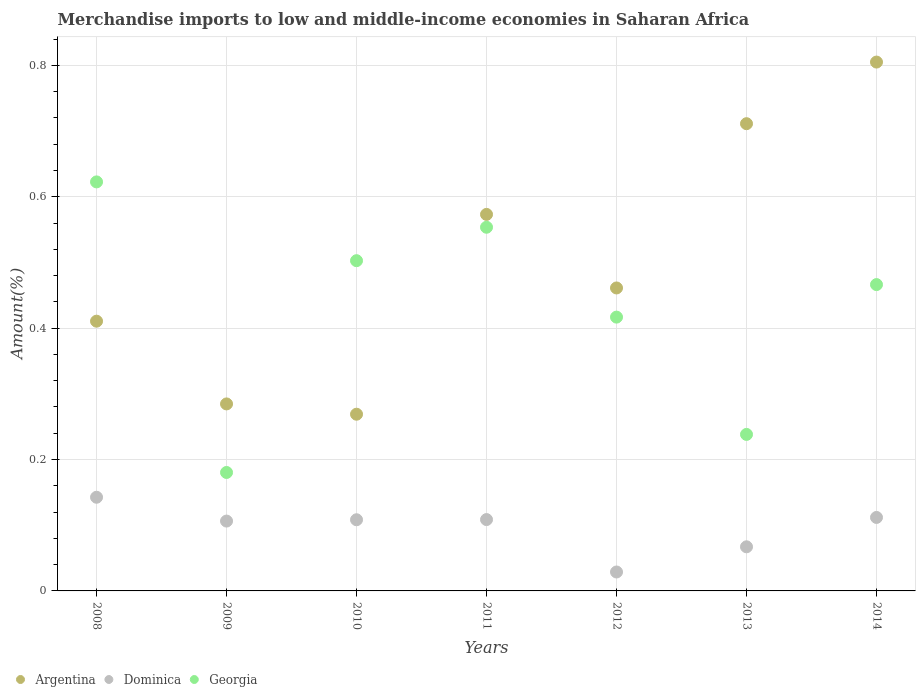Is the number of dotlines equal to the number of legend labels?
Provide a short and direct response. Yes. What is the percentage of amount earned from merchandise imports in Georgia in 2014?
Make the answer very short. 0.47. Across all years, what is the maximum percentage of amount earned from merchandise imports in Georgia?
Offer a terse response. 0.62. Across all years, what is the minimum percentage of amount earned from merchandise imports in Argentina?
Provide a succinct answer. 0.27. In which year was the percentage of amount earned from merchandise imports in Georgia maximum?
Offer a very short reply. 2008. What is the total percentage of amount earned from merchandise imports in Georgia in the graph?
Make the answer very short. 2.98. What is the difference between the percentage of amount earned from merchandise imports in Georgia in 2010 and that in 2014?
Keep it short and to the point. 0.04. What is the difference between the percentage of amount earned from merchandise imports in Georgia in 2014 and the percentage of amount earned from merchandise imports in Dominica in 2009?
Keep it short and to the point. 0.36. What is the average percentage of amount earned from merchandise imports in Dominica per year?
Provide a succinct answer. 0.1. In the year 2013, what is the difference between the percentage of amount earned from merchandise imports in Argentina and percentage of amount earned from merchandise imports in Georgia?
Make the answer very short. 0.47. What is the ratio of the percentage of amount earned from merchandise imports in Dominica in 2012 to that in 2013?
Give a very brief answer. 0.43. Is the percentage of amount earned from merchandise imports in Georgia in 2012 less than that in 2013?
Offer a terse response. No. What is the difference between the highest and the second highest percentage of amount earned from merchandise imports in Argentina?
Provide a short and direct response. 0.09. What is the difference between the highest and the lowest percentage of amount earned from merchandise imports in Dominica?
Keep it short and to the point. 0.11. Is it the case that in every year, the sum of the percentage of amount earned from merchandise imports in Argentina and percentage of amount earned from merchandise imports in Georgia  is greater than the percentage of amount earned from merchandise imports in Dominica?
Offer a terse response. Yes. Is the percentage of amount earned from merchandise imports in Georgia strictly less than the percentage of amount earned from merchandise imports in Dominica over the years?
Your answer should be very brief. No. Are the values on the major ticks of Y-axis written in scientific E-notation?
Offer a terse response. No. Does the graph contain grids?
Your answer should be compact. Yes. How many legend labels are there?
Give a very brief answer. 3. How are the legend labels stacked?
Keep it short and to the point. Horizontal. What is the title of the graph?
Offer a terse response. Merchandise imports to low and middle-income economies in Saharan Africa. What is the label or title of the X-axis?
Your answer should be compact. Years. What is the label or title of the Y-axis?
Your answer should be very brief. Amount(%). What is the Amount(%) in Argentina in 2008?
Provide a short and direct response. 0.41. What is the Amount(%) in Dominica in 2008?
Provide a short and direct response. 0.14. What is the Amount(%) of Georgia in 2008?
Make the answer very short. 0.62. What is the Amount(%) in Argentina in 2009?
Your answer should be compact. 0.28. What is the Amount(%) in Dominica in 2009?
Offer a very short reply. 0.11. What is the Amount(%) in Georgia in 2009?
Make the answer very short. 0.18. What is the Amount(%) of Argentina in 2010?
Offer a terse response. 0.27. What is the Amount(%) of Dominica in 2010?
Your answer should be very brief. 0.11. What is the Amount(%) of Georgia in 2010?
Your response must be concise. 0.5. What is the Amount(%) of Argentina in 2011?
Your answer should be very brief. 0.57. What is the Amount(%) of Dominica in 2011?
Your response must be concise. 0.11. What is the Amount(%) of Georgia in 2011?
Your answer should be compact. 0.55. What is the Amount(%) in Argentina in 2012?
Your answer should be very brief. 0.46. What is the Amount(%) of Dominica in 2012?
Give a very brief answer. 0.03. What is the Amount(%) of Georgia in 2012?
Your answer should be compact. 0.42. What is the Amount(%) in Argentina in 2013?
Offer a very short reply. 0.71. What is the Amount(%) of Dominica in 2013?
Your answer should be very brief. 0.07. What is the Amount(%) of Georgia in 2013?
Offer a terse response. 0.24. What is the Amount(%) of Argentina in 2014?
Ensure brevity in your answer.  0.81. What is the Amount(%) of Dominica in 2014?
Your answer should be very brief. 0.11. What is the Amount(%) of Georgia in 2014?
Offer a very short reply. 0.47. Across all years, what is the maximum Amount(%) in Argentina?
Offer a very short reply. 0.81. Across all years, what is the maximum Amount(%) of Dominica?
Keep it short and to the point. 0.14. Across all years, what is the maximum Amount(%) in Georgia?
Make the answer very short. 0.62. Across all years, what is the minimum Amount(%) of Argentina?
Your response must be concise. 0.27. Across all years, what is the minimum Amount(%) of Dominica?
Make the answer very short. 0.03. Across all years, what is the minimum Amount(%) of Georgia?
Offer a very short reply. 0.18. What is the total Amount(%) in Argentina in the graph?
Your answer should be compact. 3.52. What is the total Amount(%) in Dominica in the graph?
Make the answer very short. 0.67. What is the total Amount(%) of Georgia in the graph?
Your response must be concise. 2.98. What is the difference between the Amount(%) of Argentina in 2008 and that in 2009?
Keep it short and to the point. 0.13. What is the difference between the Amount(%) in Dominica in 2008 and that in 2009?
Offer a very short reply. 0.04. What is the difference between the Amount(%) of Georgia in 2008 and that in 2009?
Provide a short and direct response. 0.44. What is the difference between the Amount(%) in Argentina in 2008 and that in 2010?
Make the answer very short. 0.14. What is the difference between the Amount(%) in Dominica in 2008 and that in 2010?
Give a very brief answer. 0.03. What is the difference between the Amount(%) in Georgia in 2008 and that in 2010?
Make the answer very short. 0.12. What is the difference between the Amount(%) in Argentina in 2008 and that in 2011?
Offer a terse response. -0.16. What is the difference between the Amount(%) of Dominica in 2008 and that in 2011?
Give a very brief answer. 0.03. What is the difference between the Amount(%) of Georgia in 2008 and that in 2011?
Keep it short and to the point. 0.07. What is the difference between the Amount(%) in Argentina in 2008 and that in 2012?
Ensure brevity in your answer.  -0.05. What is the difference between the Amount(%) of Dominica in 2008 and that in 2012?
Give a very brief answer. 0.11. What is the difference between the Amount(%) in Georgia in 2008 and that in 2012?
Give a very brief answer. 0.21. What is the difference between the Amount(%) in Argentina in 2008 and that in 2013?
Your answer should be compact. -0.3. What is the difference between the Amount(%) of Dominica in 2008 and that in 2013?
Offer a very short reply. 0.08. What is the difference between the Amount(%) in Georgia in 2008 and that in 2013?
Offer a terse response. 0.38. What is the difference between the Amount(%) of Argentina in 2008 and that in 2014?
Offer a very short reply. -0.39. What is the difference between the Amount(%) of Dominica in 2008 and that in 2014?
Offer a very short reply. 0.03. What is the difference between the Amount(%) of Georgia in 2008 and that in 2014?
Offer a very short reply. 0.16. What is the difference between the Amount(%) of Argentina in 2009 and that in 2010?
Ensure brevity in your answer.  0.02. What is the difference between the Amount(%) of Dominica in 2009 and that in 2010?
Keep it short and to the point. -0. What is the difference between the Amount(%) in Georgia in 2009 and that in 2010?
Offer a very short reply. -0.32. What is the difference between the Amount(%) in Argentina in 2009 and that in 2011?
Your response must be concise. -0.29. What is the difference between the Amount(%) in Dominica in 2009 and that in 2011?
Provide a succinct answer. -0. What is the difference between the Amount(%) of Georgia in 2009 and that in 2011?
Make the answer very short. -0.37. What is the difference between the Amount(%) of Argentina in 2009 and that in 2012?
Your response must be concise. -0.18. What is the difference between the Amount(%) in Dominica in 2009 and that in 2012?
Provide a short and direct response. 0.08. What is the difference between the Amount(%) of Georgia in 2009 and that in 2012?
Your answer should be very brief. -0.24. What is the difference between the Amount(%) of Argentina in 2009 and that in 2013?
Your answer should be compact. -0.43. What is the difference between the Amount(%) in Dominica in 2009 and that in 2013?
Provide a succinct answer. 0.04. What is the difference between the Amount(%) of Georgia in 2009 and that in 2013?
Give a very brief answer. -0.06. What is the difference between the Amount(%) of Argentina in 2009 and that in 2014?
Your answer should be compact. -0.52. What is the difference between the Amount(%) in Dominica in 2009 and that in 2014?
Give a very brief answer. -0.01. What is the difference between the Amount(%) in Georgia in 2009 and that in 2014?
Ensure brevity in your answer.  -0.29. What is the difference between the Amount(%) of Argentina in 2010 and that in 2011?
Provide a succinct answer. -0.3. What is the difference between the Amount(%) of Dominica in 2010 and that in 2011?
Provide a succinct answer. -0. What is the difference between the Amount(%) of Georgia in 2010 and that in 2011?
Give a very brief answer. -0.05. What is the difference between the Amount(%) in Argentina in 2010 and that in 2012?
Make the answer very short. -0.19. What is the difference between the Amount(%) of Dominica in 2010 and that in 2012?
Offer a very short reply. 0.08. What is the difference between the Amount(%) in Georgia in 2010 and that in 2012?
Provide a short and direct response. 0.09. What is the difference between the Amount(%) in Argentina in 2010 and that in 2013?
Your response must be concise. -0.44. What is the difference between the Amount(%) in Dominica in 2010 and that in 2013?
Ensure brevity in your answer.  0.04. What is the difference between the Amount(%) in Georgia in 2010 and that in 2013?
Make the answer very short. 0.26. What is the difference between the Amount(%) of Argentina in 2010 and that in 2014?
Provide a short and direct response. -0.54. What is the difference between the Amount(%) of Dominica in 2010 and that in 2014?
Your answer should be very brief. -0. What is the difference between the Amount(%) of Georgia in 2010 and that in 2014?
Your answer should be very brief. 0.04. What is the difference between the Amount(%) of Argentina in 2011 and that in 2012?
Give a very brief answer. 0.11. What is the difference between the Amount(%) of Dominica in 2011 and that in 2012?
Your answer should be very brief. 0.08. What is the difference between the Amount(%) of Georgia in 2011 and that in 2012?
Make the answer very short. 0.14. What is the difference between the Amount(%) of Argentina in 2011 and that in 2013?
Ensure brevity in your answer.  -0.14. What is the difference between the Amount(%) of Dominica in 2011 and that in 2013?
Ensure brevity in your answer.  0.04. What is the difference between the Amount(%) in Georgia in 2011 and that in 2013?
Ensure brevity in your answer.  0.32. What is the difference between the Amount(%) in Argentina in 2011 and that in 2014?
Offer a terse response. -0.23. What is the difference between the Amount(%) of Dominica in 2011 and that in 2014?
Ensure brevity in your answer.  -0. What is the difference between the Amount(%) in Georgia in 2011 and that in 2014?
Make the answer very short. 0.09. What is the difference between the Amount(%) in Argentina in 2012 and that in 2013?
Your answer should be very brief. -0.25. What is the difference between the Amount(%) in Dominica in 2012 and that in 2013?
Give a very brief answer. -0.04. What is the difference between the Amount(%) in Georgia in 2012 and that in 2013?
Ensure brevity in your answer.  0.18. What is the difference between the Amount(%) of Argentina in 2012 and that in 2014?
Your response must be concise. -0.34. What is the difference between the Amount(%) of Dominica in 2012 and that in 2014?
Give a very brief answer. -0.08. What is the difference between the Amount(%) in Georgia in 2012 and that in 2014?
Provide a succinct answer. -0.05. What is the difference between the Amount(%) of Argentina in 2013 and that in 2014?
Give a very brief answer. -0.09. What is the difference between the Amount(%) of Dominica in 2013 and that in 2014?
Provide a short and direct response. -0.04. What is the difference between the Amount(%) in Georgia in 2013 and that in 2014?
Provide a short and direct response. -0.23. What is the difference between the Amount(%) in Argentina in 2008 and the Amount(%) in Dominica in 2009?
Your answer should be very brief. 0.3. What is the difference between the Amount(%) of Argentina in 2008 and the Amount(%) of Georgia in 2009?
Keep it short and to the point. 0.23. What is the difference between the Amount(%) of Dominica in 2008 and the Amount(%) of Georgia in 2009?
Offer a very short reply. -0.04. What is the difference between the Amount(%) in Argentina in 2008 and the Amount(%) in Dominica in 2010?
Give a very brief answer. 0.3. What is the difference between the Amount(%) of Argentina in 2008 and the Amount(%) of Georgia in 2010?
Offer a terse response. -0.09. What is the difference between the Amount(%) of Dominica in 2008 and the Amount(%) of Georgia in 2010?
Your answer should be very brief. -0.36. What is the difference between the Amount(%) of Argentina in 2008 and the Amount(%) of Dominica in 2011?
Your answer should be very brief. 0.3. What is the difference between the Amount(%) in Argentina in 2008 and the Amount(%) in Georgia in 2011?
Your answer should be compact. -0.14. What is the difference between the Amount(%) of Dominica in 2008 and the Amount(%) of Georgia in 2011?
Your answer should be very brief. -0.41. What is the difference between the Amount(%) of Argentina in 2008 and the Amount(%) of Dominica in 2012?
Give a very brief answer. 0.38. What is the difference between the Amount(%) of Argentina in 2008 and the Amount(%) of Georgia in 2012?
Your answer should be very brief. -0.01. What is the difference between the Amount(%) in Dominica in 2008 and the Amount(%) in Georgia in 2012?
Give a very brief answer. -0.27. What is the difference between the Amount(%) in Argentina in 2008 and the Amount(%) in Dominica in 2013?
Your answer should be very brief. 0.34. What is the difference between the Amount(%) in Argentina in 2008 and the Amount(%) in Georgia in 2013?
Provide a short and direct response. 0.17. What is the difference between the Amount(%) of Dominica in 2008 and the Amount(%) of Georgia in 2013?
Offer a very short reply. -0.1. What is the difference between the Amount(%) of Argentina in 2008 and the Amount(%) of Dominica in 2014?
Your answer should be very brief. 0.3. What is the difference between the Amount(%) of Argentina in 2008 and the Amount(%) of Georgia in 2014?
Ensure brevity in your answer.  -0.06. What is the difference between the Amount(%) of Dominica in 2008 and the Amount(%) of Georgia in 2014?
Ensure brevity in your answer.  -0.32. What is the difference between the Amount(%) in Argentina in 2009 and the Amount(%) in Dominica in 2010?
Your response must be concise. 0.18. What is the difference between the Amount(%) in Argentina in 2009 and the Amount(%) in Georgia in 2010?
Make the answer very short. -0.22. What is the difference between the Amount(%) of Dominica in 2009 and the Amount(%) of Georgia in 2010?
Give a very brief answer. -0.4. What is the difference between the Amount(%) in Argentina in 2009 and the Amount(%) in Dominica in 2011?
Provide a short and direct response. 0.18. What is the difference between the Amount(%) of Argentina in 2009 and the Amount(%) of Georgia in 2011?
Your response must be concise. -0.27. What is the difference between the Amount(%) in Dominica in 2009 and the Amount(%) in Georgia in 2011?
Your answer should be very brief. -0.45. What is the difference between the Amount(%) in Argentina in 2009 and the Amount(%) in Dominica in 2012?
Your answer should be compact. 0.26. What is the difference between the Amount(%) in Argentina in 2009 and the Amount(%) in Georgia in 2012?
Your answer should be very brief. -0.13. What is the difference between the Amount(%) in Dominica in 2009 and the Amount(%) in Georgia in 2012?
Provide a succinct answer. -0.31. What is the difference between the Amount(%) of Argentina in 2009 and the Amount(%) of Dominica in 2013?
Give a very brief answer. 0.22. What is the difference between the Amount(%) of Argentina in 2009 and the Amount(%) of Georgia in 2013?
Offer a very short reply. 0.05. What is the difference between the Amount(%) in Dominica in 2009 and the Amount(%) in Georgia in 2013?
Make the answer very short. -0.13. What is the difference between the Amount(%) in Argentina in 2009 and the Amount(%) in Dominica in 2014?
Offer a very short reply. 0.17. What is the difference between the Amount(%) of Argentina in 2009 and the Amount(%) of Georgia in 2014?
Offer a very short reply. -0.18. What is the difference between the Amount(%) of Dominica in 2009 and the Amount(%) of Georgia in 2014?
Offer a terse response. -0.36. What is the difference between the Amount(%) of Argentina in 2010 and the Amount(%) of Dominica in 2011?
Offer a terse response. 0.16. What is the difference between the Amount(%) in Argentina in 2010 and the Amount(%) in Georgia in 2011?
Your answer should be compact. -0.28. What is the difference between the Amount(%) of Dominica in 2010 and the Amount(%) of Georgia in 2011?
Provide a succinct answer. -0.45. What is the difference between the Amount(%) in Argentina in 2010 and the Amount(%) in Dominica in 2012?
Your answer should be very brief. 0.24. What is the difference between the Amount(%) in Argentina in 2010 and the Amount(%) in Georgia in 2012?
Provide a succinct answer. -0.15. What is the difference between the Amount(%) in Dominica in 2010 and the Amount(%) in Georgia in 2012?
Your answer should be very brief. -0.31. What is the difference between the Amount(%) of Argentina in 2010 and the Amount(%) of Dominica in 2013?
Ensure brevity in your answer.  0.2. What is the difference between the Amount(%) of Argentina in 2010 and the Amount(%) of Georgia in 2013?
Make the answer very short. 0.03. What is the difference between the Amount(%) of Dominica in 2010 and the Amount(%) of Georgia in 2013?
Give a very brief answer. -0.13. What is the difference between the Amount(%) of Argentina in 2010 and the Amount(%) of Dominica in 2014?
Your answer should be very brief. 0.16. What is the difference between the Amount(%) in Argentina in 2010 and the Amount(%) in Georgia in 2014?
Provide a succinct answer. -0.2. What is the difference between the Amount(%) of Dominica in 2010 and the Amount(%) of Georgia in 2014?
Your answer should be compact. -0.36. What is the difference between the Amount(%) in Argentina in 2011 and the Amount(%) in Dominica in 2012?
Provide a short and direct response. 0.54. What is the difference between the Amount(%) of Argentina in 2011 and the Amount(%) of Georgia in 2012?
Provide a short and direct response. 0.16. What is the difference between the Amount(%) of Dominica in 2011 and the Amount(%) of Georgia in 2012?
Provide a short and direct response. -0.31. What is the difference between the Amount(%) in Argentina in 2011 and the Amount(%) in Dominica in 2013?
Offer a terse response. 0.51. What is the difference between the Amount(%) in Argentina in 2011 and the Amount(%) in Georgia in 2013?
Offer a very short reply. 0.33. What is the difference between the Amount(%) in Dominica in 2011 and the Amount(%) in Georgia in 2013?
Your response must be concise. -0.13. What is the difference between the Amount(%) in Argentina in 2011 and the Amount(%) in Dominica in 2014?
Ensure brevity in your answer.  0.46. What is the difference between the Amount(%) in Argentina in 2011 and the Amount(%) in Georgia in 2014?
Make the answer very short. 0.11. What is the difference between the Amount(%) of Dominica in 2011 and the Amount(%) of Georgia in 2014?
Ensure brevity in your answer.  -0.36. What is the difference between the Amount(%) in Argentina in 2012 and the Amount(%) in Dominica in 2013?
Provide a succinct answer. 0.39. What is the difference between the Amount(%) of Argentina in 2012 and the Amount(%) of Georgia in 2013?
Offer a very short reply. 0.22. What is the difference between the Amount(%) of Dominica in 2012 and the Amount(%) of Georgia in 2013?
Offer a very short reply. -0.21. What is the difference between the Amount(%) of Argentina in 2012 and the Amount(%) of Dominica in 2014?
Provide a short and direct response. 0.35. What is the difference between the Amount(%) in Argentina in 2012 and the Amount(%) in Georgia in 2014?
Provide a succinct answer. -0.01. What is the difference between the Amount(%) of Dominica in 2012 and the Amount(%) of Georgia in 2014?
Provide a succinct answer. -0.44. What is the difference between the Amount(%) in Argentina in 2013 and the Amount(%) in Dominica in 2014?
Provide a short and direct response. 0.6. What is the difference between the Amount(%) in Argentina in 2013 and the Amount(%) in Georgia in 2014?
Your response must be concise. 0.24. What is the difference between the Amount(%) of Dominica in 2013 and the Amount(%) of Georgia in 2014?
Your response must be concise. -0.4. What is the average Amount(%) of Argentina per year?
Offer a terse response. 0.5. What is the average Amount(%) of Dominica per year?
Offer a terse response. 0.1. What is the average Amount(%) in Georgia per year?
Keep it short and to the point. 0.43. In the year 2008, what is the difference between the Amount(%) of Argentina and Amount(%) of Dominica?
Keep it short and to the point. 0.27. In the year 2008, what is the difference between the Amount(%) of Argentina and Amount(%) of Georgia?
Offer a terse response. -0.21. In the year 2008, what is the difference between the Amount(%) in Dominica and Amount(%) in Georgia?
Offer a very short reply. -0.48. In the year 2009, what is the difference between the Amount(%) in Argentina and Amount(%) in Dominica?
Offer a very short reply. 0.18. In the year 2009, what is the difference between the Amount(%) of Argentina and Amount(%) of Georgia?
Your answer should be very brief. 0.1. In the year 2009, what is the difference between the Amount(%) of Dominica and Amount(%) of Georgia?
Ensure brevity in your answer.  -0.07. In the year 2010, what is the difference between the Amount(%) in Argentina and Amount(%) in Dominica?
Offer a terse response. 0.16. In the year 2010, what is the difference between the Amount(%) of Argentina and Amount(%) of Georgia?
Offer a very short reply. -0.23. In the year 2010, what is the difference between the Amount(%) in Dominica and Amount(%) in Georgia?
Your answer should be very brief. -0.39. In the year 2011, what is the difference between the Amount(%) of Argentina and Amount(%) of Dominica?
Provide a short and direct response. 0.46. In the year 2011, what is the difference between the Amount(%) in Argentina and Amount(%) in Georgia?
Your answer should be very brief. 0.02. In the year 2011, what is the difference between the Amount(%) in Dominica and Amount(%) in Georgia?
Provide a short and direct response. -0.45. In the year 2012, what is the difference between the Amount(%) in Argentina and Amount(%) in Dominica?
Your answer should be very brief. 0.43. In the year 2012, what is the difference between the Amount(%) in Argentina and Amount(%) in Georgia?
Give a very brief answer. 0.04. In the year 2012, what is the difference between the Amount(%) in Dominica and Amount(%) in Georgia?
Keep it short and to the point. -0.39. In the year 2013, what is the difference between the Amount(%) of Argentina and Amount(%) of Dominica?
Make the answer very short. 0.64. In the year 2013, what is the difference between the Amount(%) in Argentina and Amount(%) in Georgia?
Make the answer very short. 0.47. In the year 2013, what is the difference between the Amount(%) in Dominica and Amount(%) in Georgia?
Offer a very short reply. -0.17. In the year 2014, what is the difference between the Amount(%) in Argentina and Amount(%) in Dominica?
Give a very brief answer. 0.69. In the year 2014, what is the difference between the Amount(%) in Argentina and Amount(%) in Georgia?
Your response must be concise. 0.34. In the year 2014, what is the difference between the Amount(%) in Dominica and Amount(%) in Georgia?
Provide a short and direct response. -0.35. What is the ratio of the Amount(%) of Argentina in 2008 to that in 2009?
Your response must be concise. 1.44. What is the ratio of the Amount(%) in Dominica in 2008 to that in 2009?
Offer a very short reply. 1.34. What is the ratio of the Amount(%) in Georgia in 2008 to that in 2009?
Provide a succinct answer. 3.45. What is the ratio of the Amount(%) of Argentina in 2008 to that in 2010?
Offer a terse response. 1.53. What is the ratio of the Amount(%) of Dominica in 2008 to that in 2010?
Provide a succinct answer. 1.32. What is the ratio of the Amount(%) of Georgia in 2008 to that in 2010?
Make the answer very short. 1.24. What is the ratio of the Amount(%) in Argentina in 2008 to that in 2011?
Your answer should be compact. 0.72. What is the ratio of the Amount(%) of Dominica in 2008 to that in 2011?
Your answer should be very brief. 1.31. What is the ratio of the Amount(%) of Georgia in 2008 to that in 2011?
Make the answer very short. 1.12. What is the ratio of the Amount(%) of Argentina in 2008 to that in 2012?
Your answer should be compact. 0.89. What is the ratio of the Amount(%) of Dominica in 2008 to that in 2012?
Make the answer very short. 4.95. What is the ratio of the Amount(%) of Georgia in 2008 to that in 2012?
Keep it short and to the point. 1.49. What is the ratio of the Amount(%) in Argentina in 2008 to that in 2013?
Your answer should be very brief. 0.58. What is the ratio of the Amount(%) in Dominica in 2008 to that in 2013?
Make the answer very short. 2.12. What is the ratio of the Amount(%) in Georgia in 2008 to that in 2013?
Offer a terse response. 2.61. What is the ratio of the Amount(%) in Argentina in 2008 to that in 2014?
Offer a terse response. 0.51. What is the ratio of the Amount(%) in Dominica in 2008 to that in 2014?
Offer a terse response. 1.27. What is the ratio of the Amount(%) in Georgia in 2008 to that in 2014?
Your response must be concise. 1.34. What is the ratio of the Amount(%) of Argentina in 2009 to that in 2010?
Your response must be concise. 1.06. What is the ratio of the Amount(%) in Dominica in 2009 to that in 2010?
Provide a succinct answer. 0.98. What is the ratio of the Amount(%) in Georgia in 2009 to that in 2010?
Provide a short and direct response. 0.36. What is the ratio of the Amount(%) in Argentina in 2009 to that in 2011?
Your response must be concise. 0.5. What is the ratio of the Amount(%) in Dominica in 2009 to that in 2011?
Offer a terse response. 0.98. What is the ratio of the Amount(%) of Georgia in 2009 to that in 2011?
Give a very brief answer. 0.33. What is the ratio of the Amount(%) of Argentina in 2009 to that in 2012?
Provide a succinct answer. 0.62. What is the ratio of the Amount(%) of Dominica in 2009 to that in 2012?
Provide a short and direct response. 3.69. What is the ratio of the Amount(%) of Georgia in 2009 to that in 2012?
Offer a terse response. 0.43. What is the ratio of the Amount(%) in Argentina in 2009 to that in 2013?
Offer a very short reply. 0.4. What is the ratio of the Amount(%) in Dominica in 2009 to that in 2013?
Ensure brevity in your answer.  1.58. What is the ratio of the Amount(%) of Georgia in 2009 to that in 2013?
Your answer should be compact. 0.76. What is the ratio of the Amount(%) of Argentina in 2009 to that in 2014?
Your answer should be very brief. 0.35. What is the ratio of the Amount(%) of Dominica in 2009 to that in 2014?
Provide a short and direct response. 0.95. What is the ratio of the Amount(%) in Georgia in 2009 to that in 2014?
Provide a short and direct response. 0.39. What is the ratio of the Amount(%) of Argentina in 2010 to that in 2011?
Your answer should be very brief. 0.47. What is the ratio of the Amount(%) of Dominica in 2010 to that in 2011?
Your answer should be compact. 1. What is the ratio of the Amount(%) in Georgia in 2010 to that in 2011?
Make the answer very short. 0.91. What is the ratio of the Amount(%) in Argentina in 2010 to that in 2012?
Keep it short and to the point. 0.58. What is the ratio of the Amount(%) in Dominica in 2010 to that in 2012?
Your response must be concise. 3.76. What is the ratio of the Amount(%) of Georgia in 2010 to that in 2012?
Give a very brief answer. 1.21. What is the ratio of the Amount(%) of Argentina in 2010 to that in 2013?
Keep it short and to the point. 0.38. What is the ratio of the Amount(%) of Dominica in 2010 to that in 2013?
Offer a very short reply. 1.61. What is the ratio of the Amount(%) in Georgia in 2010 to that in 2013?
Ensure brevity in your answer.  2.11. What is the ratio of the Amount(%) in Argentina in 2010 to that in 2014?
Keep it short and to the point. 0.33. What is the ratio of the Amount(%) in Dominica in 2010 to that in 2014?
Ensure brevity in your answer.  0.97. What is the ratio of the Amount(%) in Georgia in 2010 to that in 2014?
Offer a very short reply. 1.08. What is the ratio of the Amount(%) in Argentina in 2011 to that in 2012?
Offer a terse response. 1.24. What is the ratio of the Amount(%) in Dominica in 2011 to that in 2012?
Your answer should be compact. 3.77. What is the ratio of the Amount(%) in Georgia in 2011 to that in 2012?
Your answer should be compact. 1.33. What is the ratio of the Amount(%) of Argentina in 2011 to that in 2013?
Your answer should be compact. 0.81. What is the ratio of the Amount(%) of Dominica in 2011 to that in 2013?
Offer a terse response. 1.62. What is the ratio of the Amount(%) of Georgia in 2011 to that in 2013?
Keep it short and to the point. 2.32. What is the ratio of the Amount(%) in Argentina in 2011 to that in 2014?
Your response must be concise. 0.71. What is the ratio of the Amount(%) of Dominica in 2011 to that in 2014?
Your answer should be compact. 0.97. What is the ratio of the Amount(%) in Georgia in 2011 to that in 2014?
Ensure brevity in your answer.  1.19. What is the ratio of the Amount(%) of Argentina in 2012 to that in 2013?
Provide a short and direct response. 0.65. What is the ratio of the Amount(%) of Dominica in 2012 to that in 2013?
Provide a short and direct response. 0.43. What is the ratio of the Amount(%) in Georgia in 2012 to that in 2013?
Keep it short and to the point. 1.75. What is the ratio of the Amount(%) in Argentina in 2012 to that in 2014?
Your answer should be very brief. 0.57. What is the ratio of the Amount(%) in Dominica in 2012 to that in 2014?
Offer a terse response. 0.26. What is the ratio of the Amount(%) of Georgia in 2012 to that in 2014?
Give a very brief answer. 0.89. What is the ratio of the Amount(%) of Argentina in 2013 to that in 2014?
Offer a terse response. 0.88. What is the ratio of the Amount(%) in Dominica in 2013 to that in 2014?
Ensure brevity in your answer.  0.6. What is the ratio of the Amount(%) in Georgia in 2013 to that in 2014?
Provide a succinct answer. 0.51. What is the difference between the highest and the second highest Amount(%) of Argentina?
Your answer should be very brief. 0.09. What is the difference between the highest and the second highest Amount(%) of Dominica?
Make the answer very short. 0.03. What is the difference between the highest and the second highest Amount(%) of Georgia?
Offer a terse response. 0.07. What is the difference between the highest and the lowest Amount(%) of Argentina?
Keep it short and to the point. 0.54. What is the difference between the highest and the lowest Amount(%) of Dominica?
Provide a short and direct response. 0.11. What is the difference between the highest and the lowest Amount(%) of Georgia?
Your answer should be very brief. 0.44. 